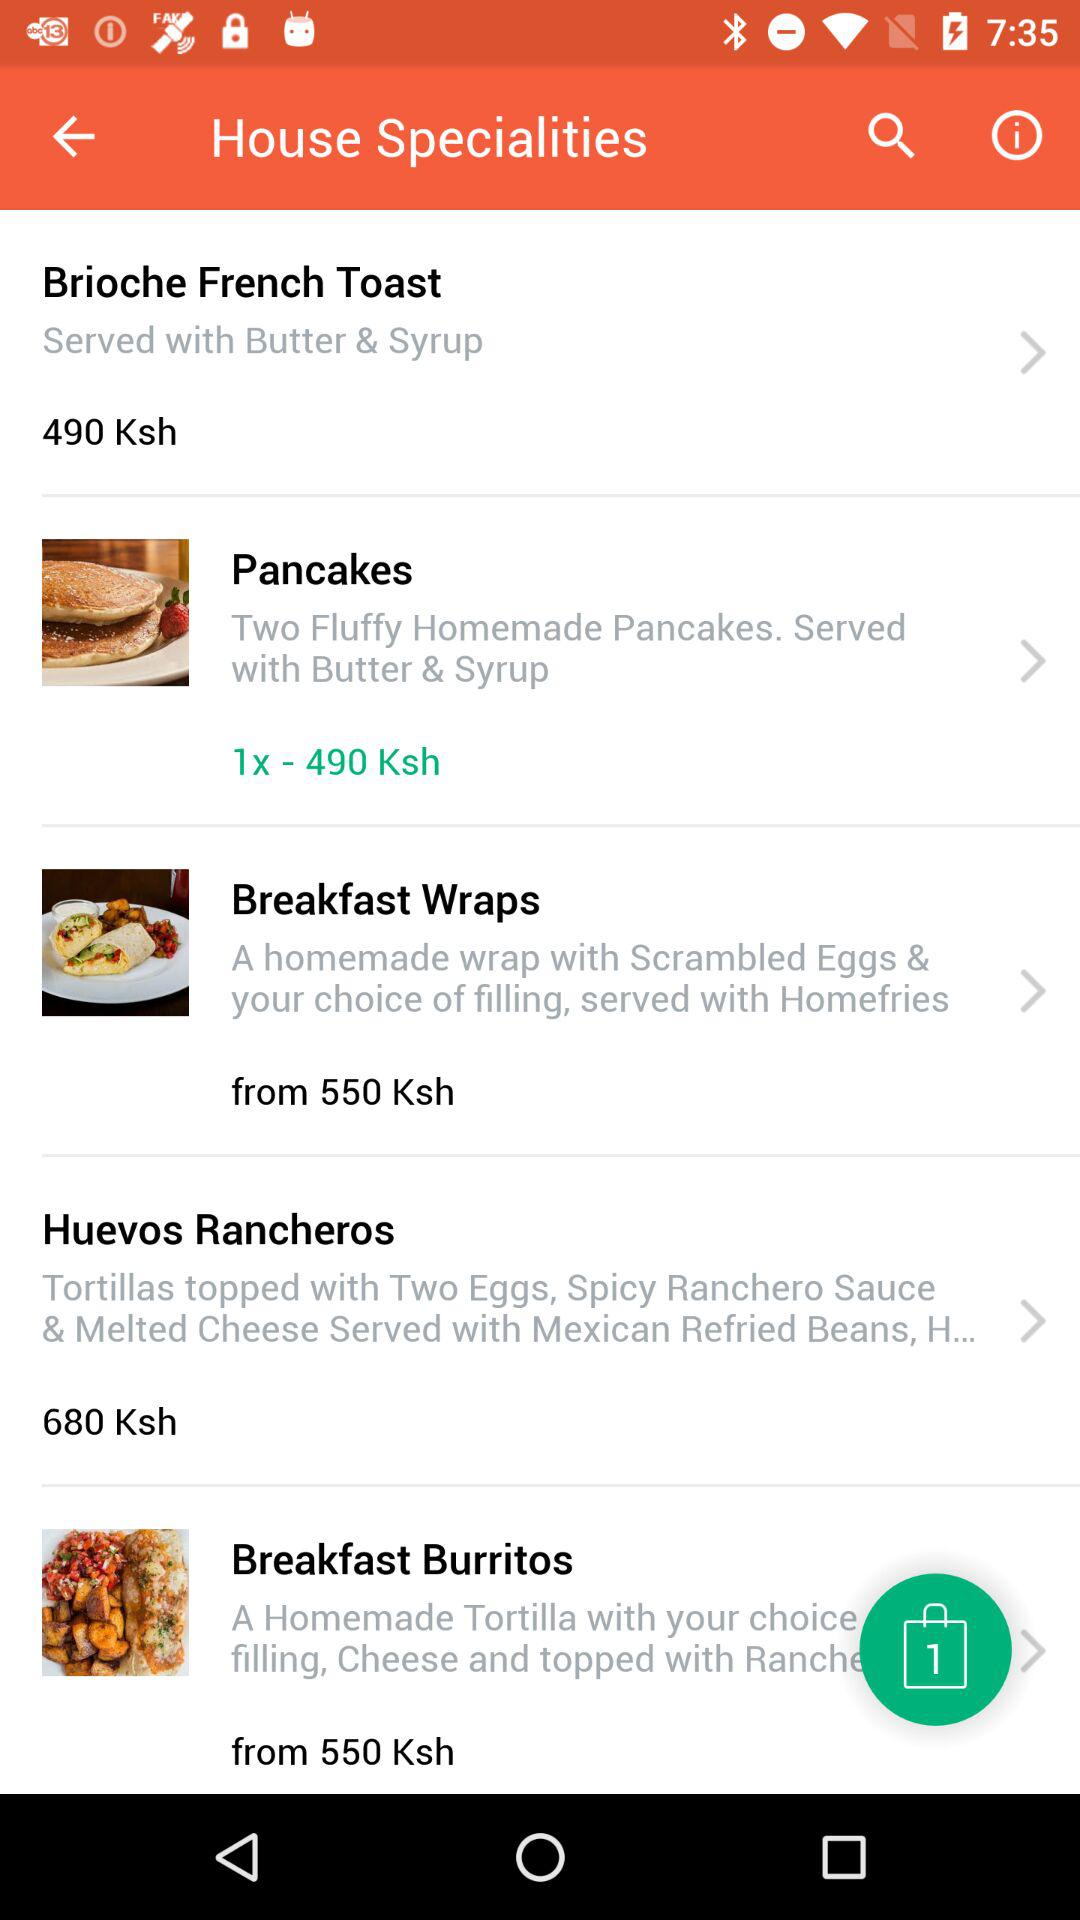What is the starting price for Breakfast Burritos? The starting price is 550 shillings. 